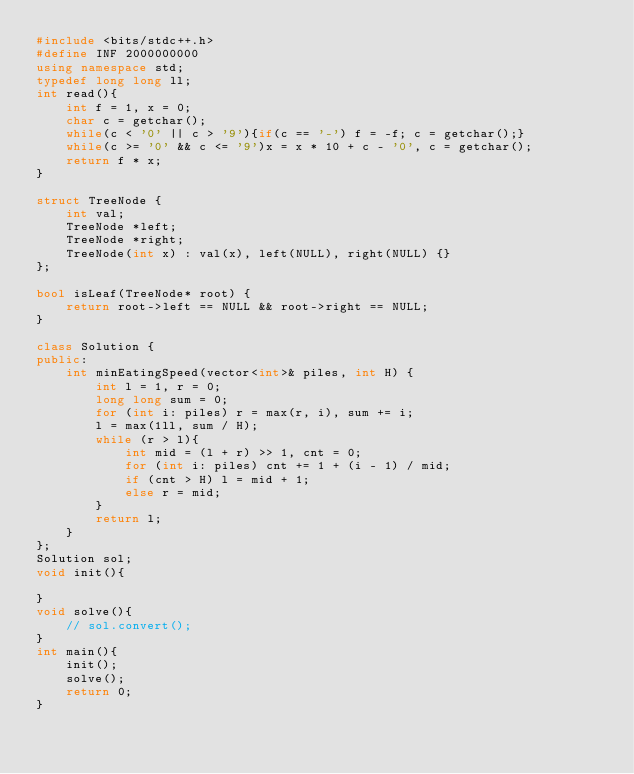Convert code to text. <code><loc_0><loc_0><loc_500><loc_500><_C++_>#include <bits/stdc++.h>
#define INF 2000000000
using namespace std;
typedef long long ll;
int read(){
	int f = 1, x = 0;
	char c = getchar();
	while(c < '0' || c > '9'){if(c == '-') f = -f; c = getchar();}
	while(c >= '0' && c <= '9')x = x * 10 + c - '0', c = getchar();
	return f * x; 
}

struct TreeNode {
    int val;
    TreeNode *left;
    TreeNode *right;
    TreeNode(int x) : val(x), left(NULL), right(NULL) {}
};

bool isLeaf(TreeNode* root) {
    return root->left == NULL && root->right == NULL;
}

class Solution {
public:
    int minEatingSpeed(vector<int>& piles, int H) {
        int l = 1, r = 0;
        long long sum = 0;
        for (int i: piles) r = max(r, i), sum += i;
        l = max(1ll, sum / H);
        while (r > l){
            int mid = (l + r) >> 1, cnt = 0;
            for (int i: piles) cnt += 1 + (i - 1) / mid;
            if (cnt > H) l = mid + 1;
            else r = mid;
        }
        return l;
    }
};
Solution sol;
void init(){
    
}
void solve(){
	// sol.convert();
}
int main(){
	init();
	solve();
	return 0;
}
</code> 